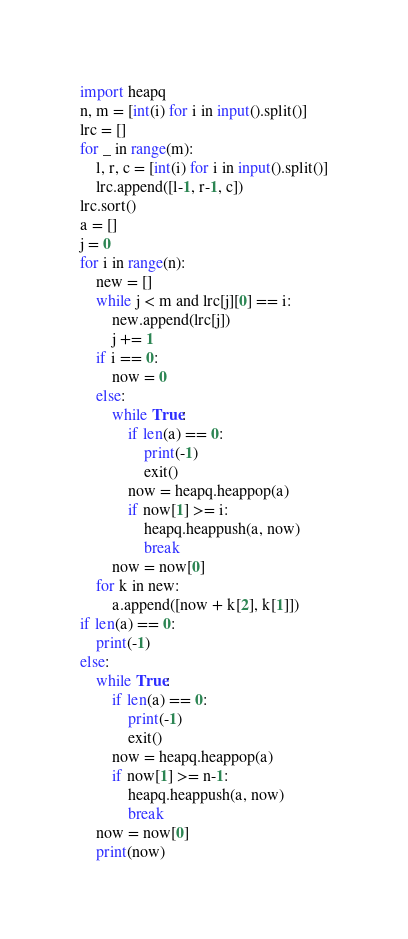<code> <loc_0><loc_0><loc_500><loc_500><_Python_>import heapq
n, m = [int(i) for i in input().split()]
lrc = []
for _ in range(m):
    l, r, c = [int(i) for i in input().split()]
    lrc.append([l-1, r-1, c])
lrc.sort()
a = []
j = 0
for i in range(n):
    new = []
    while j < m and lrc[j][0] == i:
        new.append(lrc[j])
        j += 1
    if i == 0:
        now = 0
    else:
        while True:
            if len(a) == 0:
                print(-1)
                exit()
            now = heapq.heappop(a)
            if now[1] >= i:
                heapq.heappush(a, now)
                break
        now = now[0]
    for k in new:
        a.append([now + k[2], k[1]])
if len(a) == 0:
    print(-1)
else:
    while True:
        if len(a) == 0:
            print(-1)
            exit()
        now = heapq.heappop(a)
        if now[1] >= n-1:
            heapq.heappush(a, now)
            break
    now = now[0]
    print(now)
</code> 